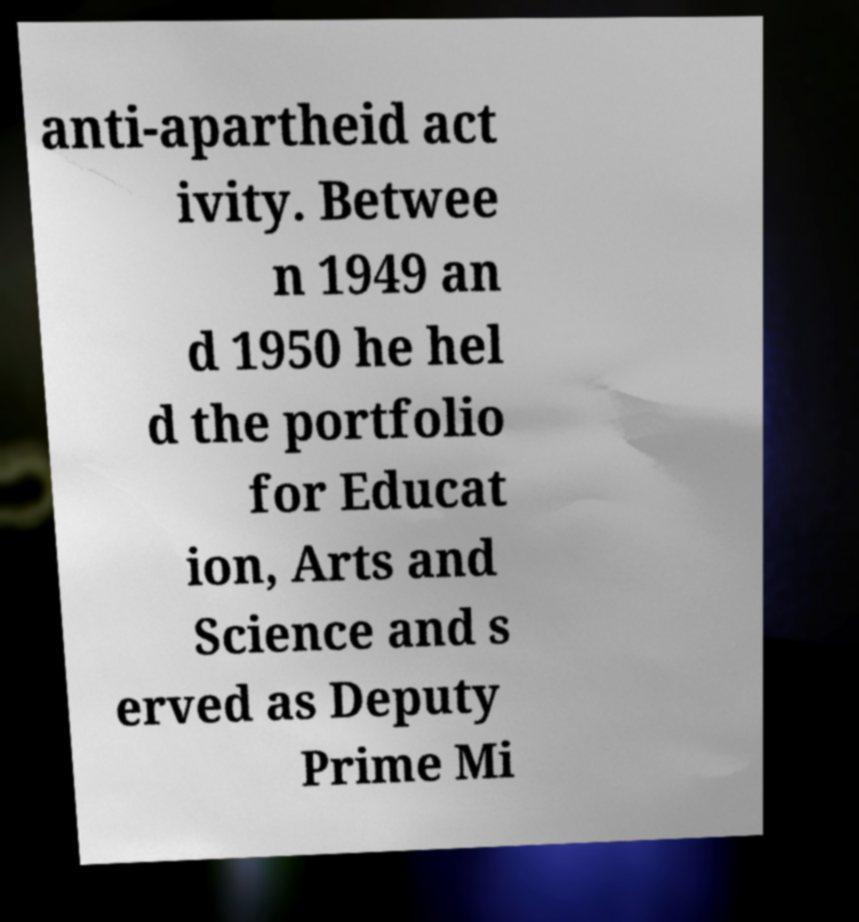Can you accurately transcribe the text from the provided image for me? anti-apartheid act ivity. Betwee n 1949 an d 1950 he hel d the portfolio for Educat ion, Arts and Science and s erved as Deputy Prime Mi 